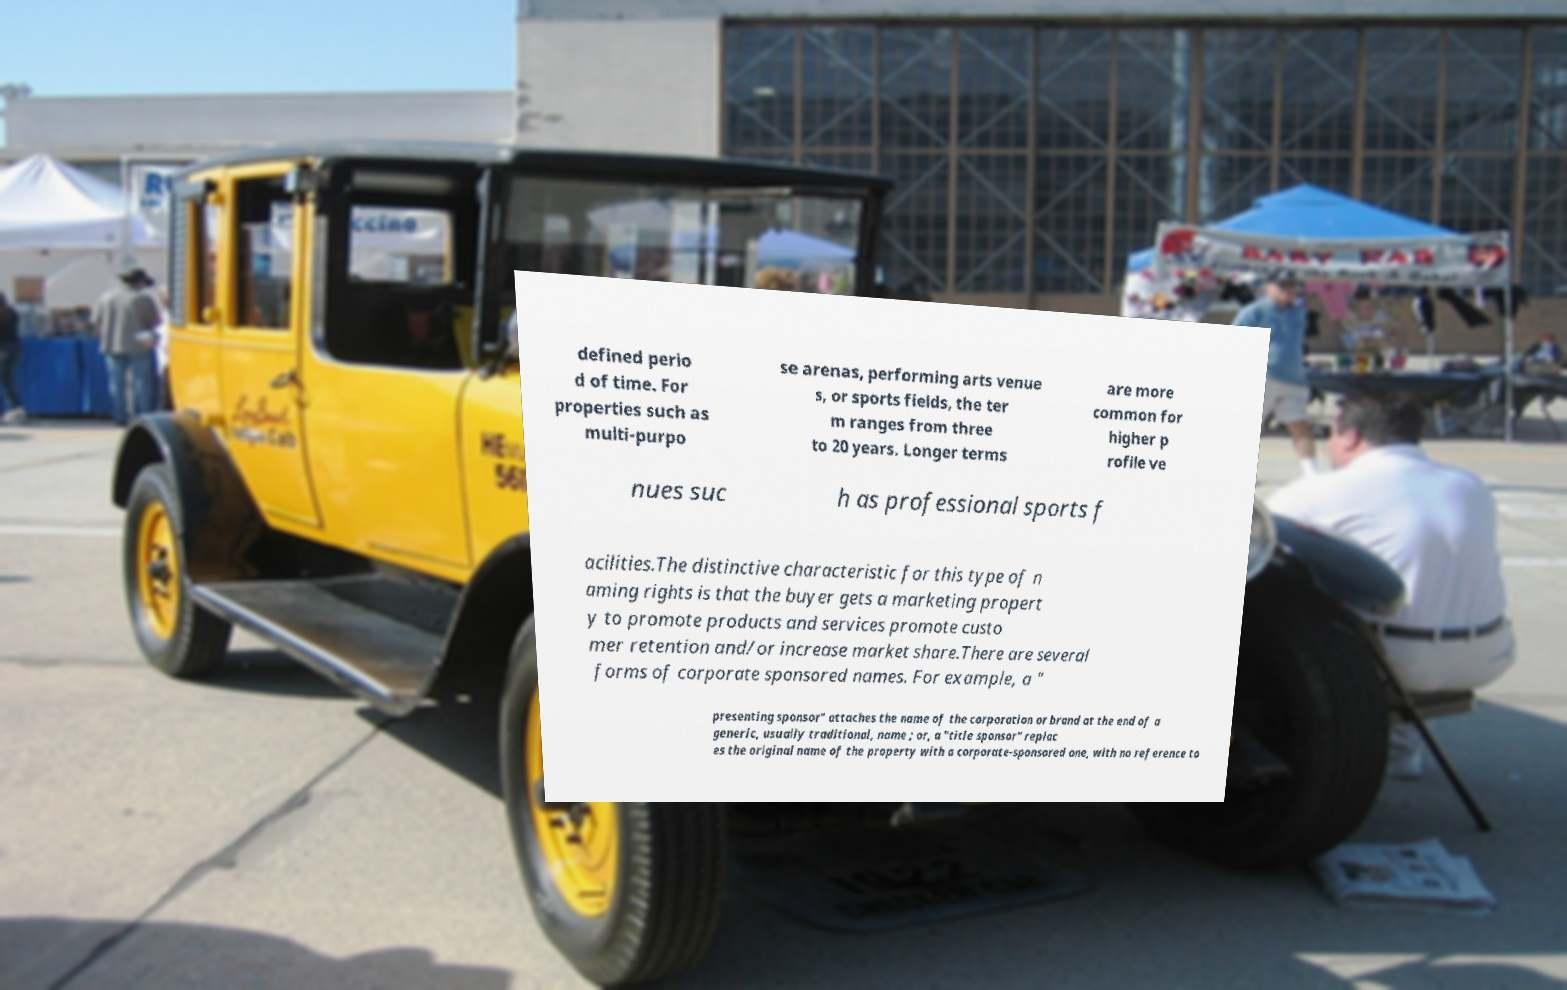For documentation purposes, I need the text within this image transcribed. Could you provide that? defined perio d of time. For properties such as multi-purpo se arenas, performing arts venue s, or sports fields, the ter m ranges from three to 20 years. Longer terms are more common for higher p rofile ve nues suc h as professional sports f acilities.The distinctive characteristic for this type of n aming rights is that the buyer gets a marketing propert y to promote products and services promote custo mer retention and/or increase market share.There are several forms of corporate sponsored names. For example, a " presenting sponsor" attaches the name of the corporation or brand at the end of a generic, usually traditional, name ; or, a "title sponsor" replac es the original name of the property with a corporate-sponsored one, with no reference to 